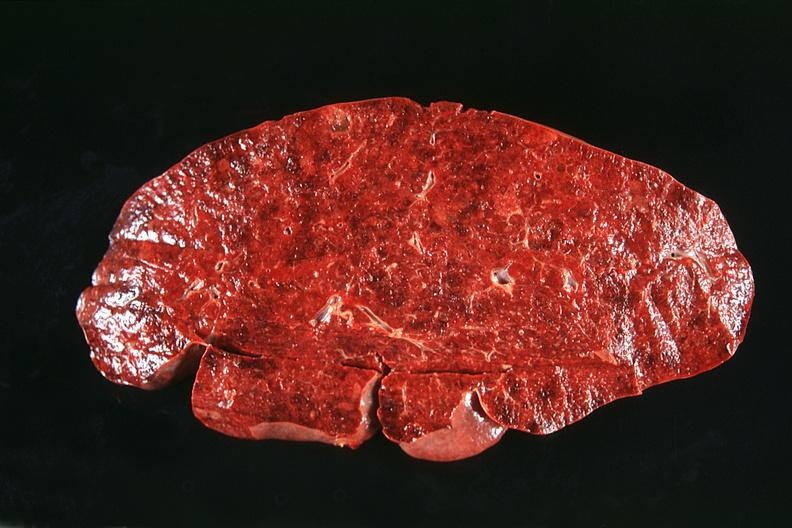what is present?
Answer the question using a single word or phrase. Hematologic 